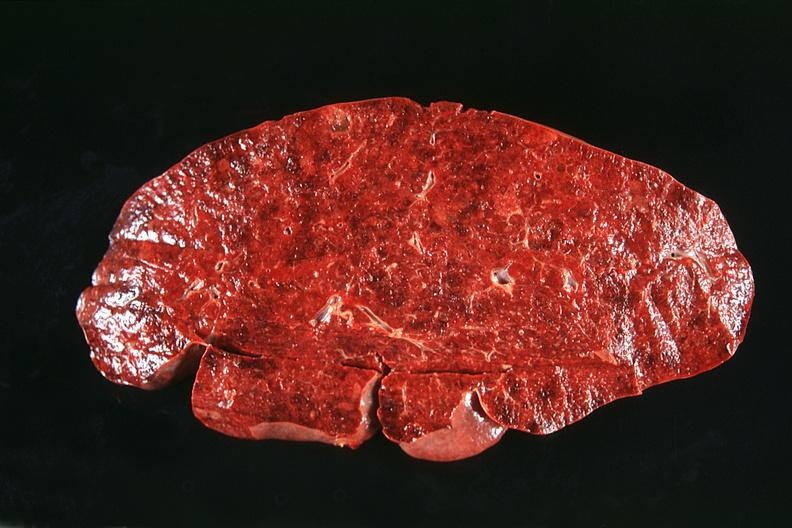what is present?
Answer the question using a single word or phrase. Hematologic 